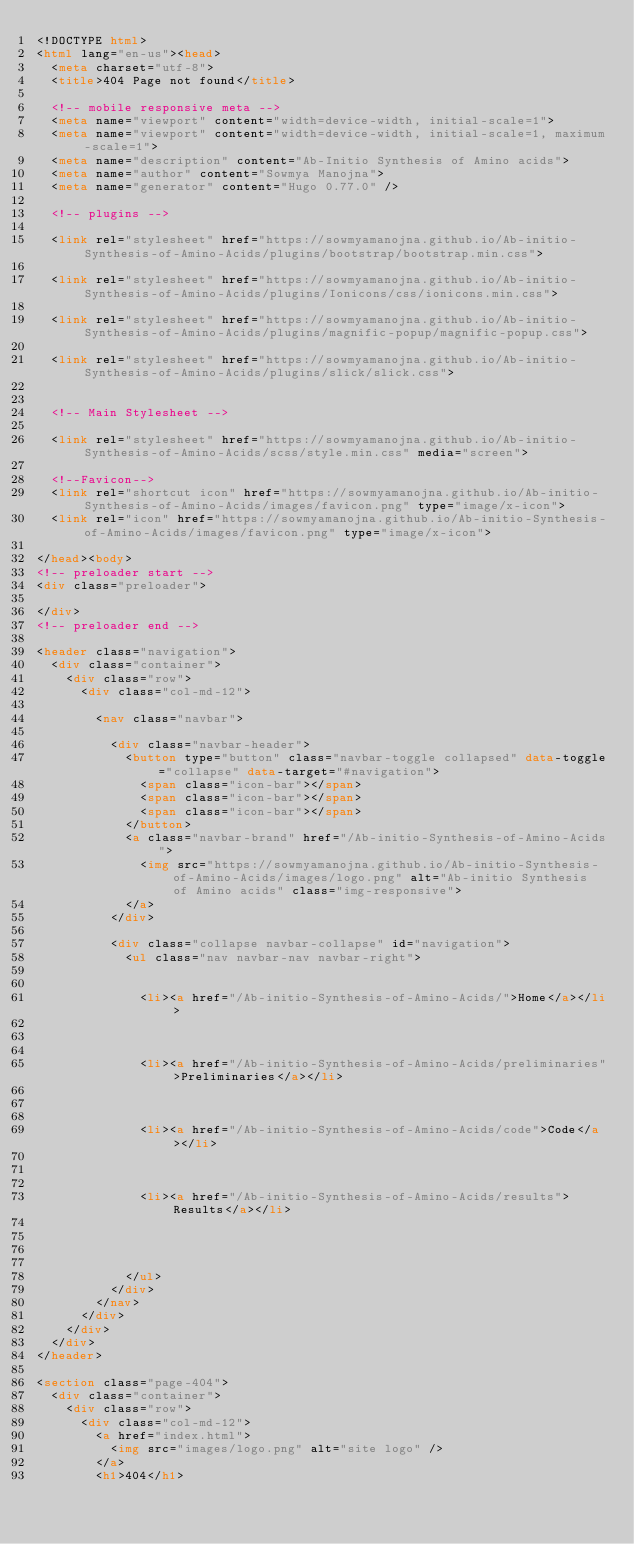Convert code to text. <code><loc_0><loc_0><loc_500><loc_500><_HTML_><!DOCTYPE html>
<html lang="en-us"><head>
  <meta charset="utf-8">
  <title>404 Page not found</title>

  <!-- mobile responsive meta -->
  <meta name="viewport" content="width=device-width, initial-scale=1">
  <meta name="viewport" content="width=device-width, initial-scale=1, maximum-scale=1">
  <meta name="description" content="Ab-Initio Synthesis of Amino acids">
  <meta name="author" content="Sowmya Manojna">
  <meta name="generator" content="Hugo 0.77.0" />

  <!-- plugins -->
  
  <link rel="stylesheet" href="https://sowmyamanojna.github.io/Ab-initio-Synthesis-of-Amino-Acids/plugins/bootstrap/bootstrap.min.css">
  
  <link rel="stylesheet" href="https://sowmyamanojna.github.io/Ab-initio-Synthesis-of-Amino-Acids/plugins/Ionicons/css/ionicons.min.css">
  
  <link rel="stylesheet" href="https://sowmyamanojna.github.io/Ab-initio-Synthesis-of-Amino-Acids/plugins/magnific-popup/magnific-popup.css">
  
  <link rel="stylesheet" href="https://sowmyamanojna.github.io/Ab-initio-Synthesis-of-Amino-Acids/plugins/slick/slick.css">
  

  <!-- Main Stylesheet -->
  
  <link rel="stylesheet" href="https://sowmyamanojna.github.io/Ab-initio-Synthesis-of-Amino-Acids/scss/style.min.css" media="screen">

  <!--Favicon-->
  <link rel="shortcut icon" href="https://sowmyamanojna.github.io/Ab-initio-Synthesis-of-Amino-Acids/images/favicon.png" type="image/x-icon">
  <link rel="icon" href="https://sowmyamanojna.github.io/Ab-initio-Synthesis-of-Amino-Acids/images/favicon.png" type="image/x-icon">

</head><body>
<!-- preloader start -->
<div class="preloader">
  
</div>
<!-- preloader end -->

<header class="navigation">
  <div class="container">
    <div class="row">
      <div class="col-md-12">
        
        <nav class="navbar">
          
          <div class="navbar-header">
            <button type="button" class="navbar-toggle collapsed" data-toggle="collapse" data-target="#navigation">
              <span class="icon-bar"></span>
              <span class="icon-bar"></span>
              <span class="icon-bar"></span>
            </button>
            <a class="navbar-brand" href="/Ab-initio-Synthesis-of-Amino-Acids">
              <img src="https://sowmyamanojna.github.io/Ab-initio-Synthesis-of-Amino-Acids/images/logo.png" alt="Ab-initio Synthesis of Amino acids" class="img-responsive">
            </a>
          </div>
          
          <div class="collapse navbar-collapse" id="navigation">
            <ul class="nav navbar-nav navbar-right">
              
              
              <li><a href="/Ab-initio-Synthesis-of-Amino-Acids/">Home</a></li>
              
              
              
              <li><a href="/Ab-initio-Synthesis-of-Amino-Acids/preliminaries">Preliminaries</a></li>
              
              
              
              <li><a href="/Ab-initio-Synthesis-of-Amino-Acids/code">Code</a></li>
              
              
              
              <li><a href="/Ab-initio-Synthesis-of-Amino-Acids/results">Results</a></li>
              
              

              
            </ul>
          </div>
        </nav>
      </div>
    </div>
  </div>
</header>

<section class="page-404">
  <div class="container">
    <div class="row">
      <div class="col-md-12">
        <a href="index.html">
          <img src="images/logo.png" alt="site logo" />
        </a>
        <h1>404</h1></code> 